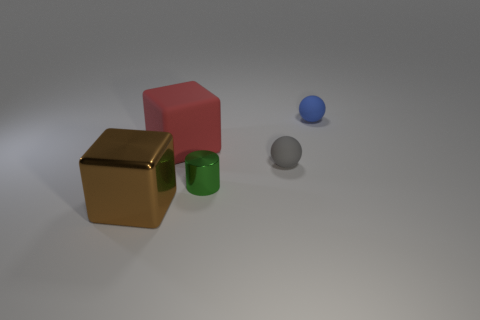What number of objects are tiny green metallic cylinders or rubber things that are in front of the tiny blue rubber thing?
Offer a very short reply. 3. Does the cube that is right of the big brown thing have the same size as the block that is in front of the small green object?
Keep it short and to the point. Yes. Is there a big brown block made of the same material as the small cylinder?
Give a very brief answer. Yes. The gray object has what shape?
Ensure brevity in your answer.  Sphere. There is a small rubber object to the left of the tiny matte sphere to the right of the tiny gray rubber thing; what shape is it?
Keep it short and to the point. Sphere. What number of other things are there of the same shape as the tiny green object?
Your answer should be very brief. 0. How big is the rubber ball that is in front of the thing that is to the right of the tiny gray rubber sphere?
Make the answer very short. Small. Is there a large red object?
Give a very brief answer. Yes. There is a thing that is behind the large red cube; how many tiny green metallic things are in front of it?
Provide a short and direct response. 1. There is a matte thing that is to the left of the gray object; what is its shape?
Offer a terse response. Cube. 